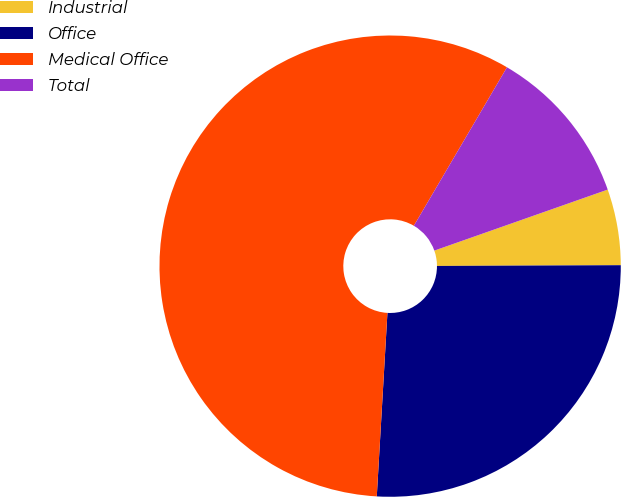Convert chart to OTSL. <chart><loc_0><loc_0><loc_500><loc_500><pie_chart><fcel>Industrial<fcel>Office<fcel>Medical Office<fcel>Total<nl><fcel>5.32%<fcel>25.99%<fcel>57.54%<fcel>11.16%<nl></chart> 